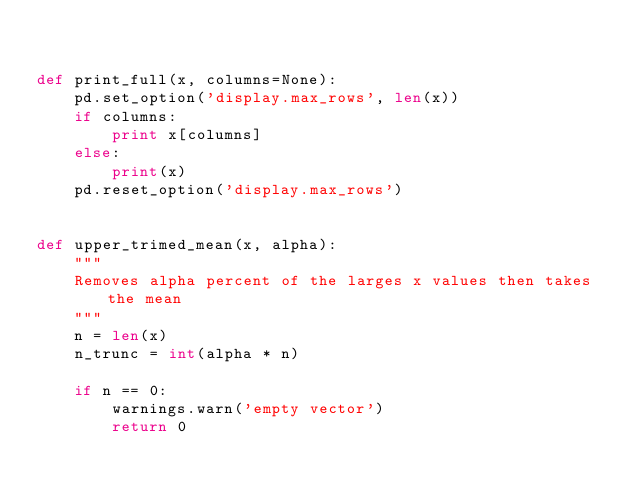<code> <loc_0><loc_0><loc_500><loc_500><_Python_>

def print_full(x, columns=None):
    pd.set_option('display.max_rows', len(x))
    if columns:
        print x[columns]
    else:
        print(x)
    pd.reset_option('display.max_rows')


def upper_trimed_mean(x, alpha):
    """
    Removes alpha percent of the larges x values then takes the mean
    """
    n = len(x)
    n_trunc = int(alpha * n)

    if n == 0:
        warnings.warn('empty vector')
        return 0
</code> 